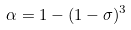Convert formula to latex. <formula><loc_0><loc_0><loc_500><loc_500>\alpha = 1 - ( 1 - \sigma ) ^ { 3 }</formula> 